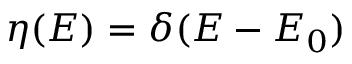<formula> <loc_0><loc_0><loc_500><loc_500>\eta ( E ) = \delta ( E - E _ { 0 } )</formula> 